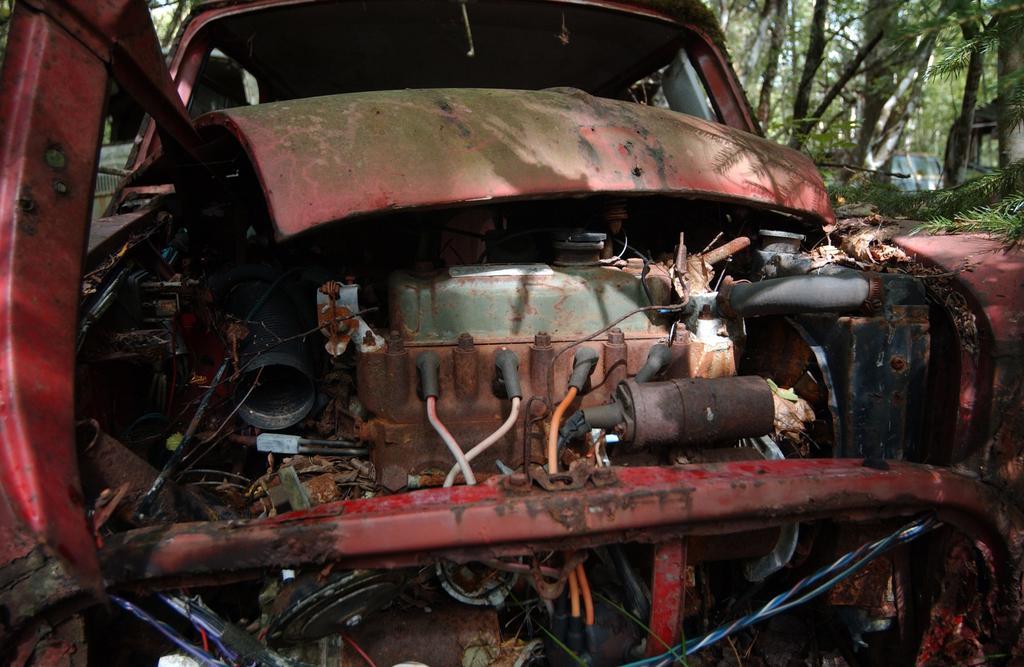In one or two sentences, can you explain what this image depicts? Here we can see a vehicle and vehicle parts. Background there are trees. 